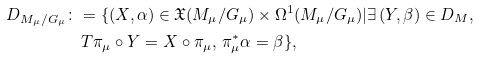Convert formula to latex. <formula><loc_0><loc_0><loc_500><loc_500>D _ { M _ { \mu } / G _ { \mu } } \colon & = \{ ( X , \alpha ) \in \mathfrak { X } ( M _ { \mu } / G _ { \mu } ) \times \Omega ^ { 1 } ( M _ { \mu } / G _ { \mu } ) | \exists \, ( Y , \beta ) \in D _ { M } , \\ & \, T \pi _ { \mu } \circ Y = X \circ \pi _ { \mu } , \, \pi _ { \mu } ^ { \ast } \alpha = \beta \} ,</formula> 